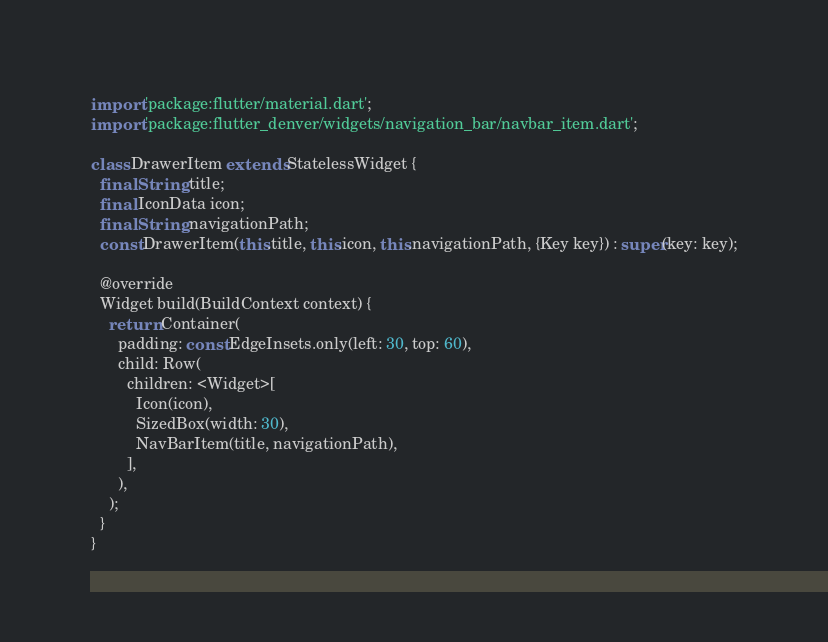Convert code to text. <code><loc_0><loc_0><loc_500><loc_500><_Dart_>import 'package:flutter/material.dart';
import 'package:flutter_denver/widgets/navigation_bar/navbar_item.dart';

class DrawerItem extends StatelessWidget {
  final String title;
  final IconData icon;
  final String navigationPath;
  const DrawerItem(this.title, this.icon, this.navigationPath, {Key key}) : super(key: key);

  @override
  Widget build(BuildContext context) {
    return Container(
      padding: const EdgeInsets.only(left: 30, top: 60),
      child: Row(
        children: <Widget>[
          Icon(icon),
          SizedBox(width: 30),
          NavBarItem(title, navigationPath),
        ],
      ),
    );
  }
}
</code> 